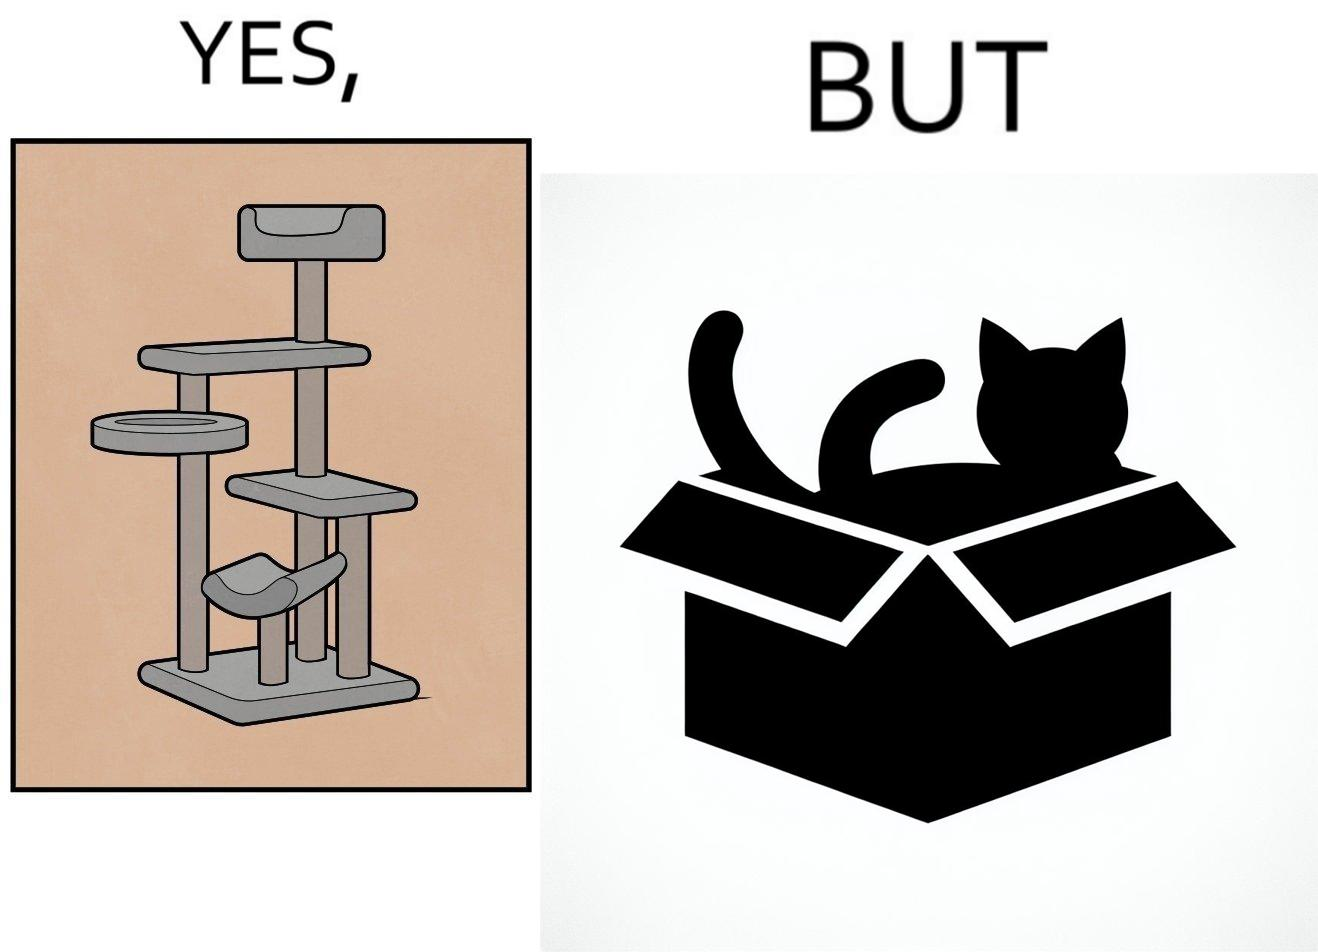Describe what you see in this image. The images are funny since even though a cat tree is bought for cats to play with, cats would usually rather play with inexpensive cardboard boxes because they enjoy it more 